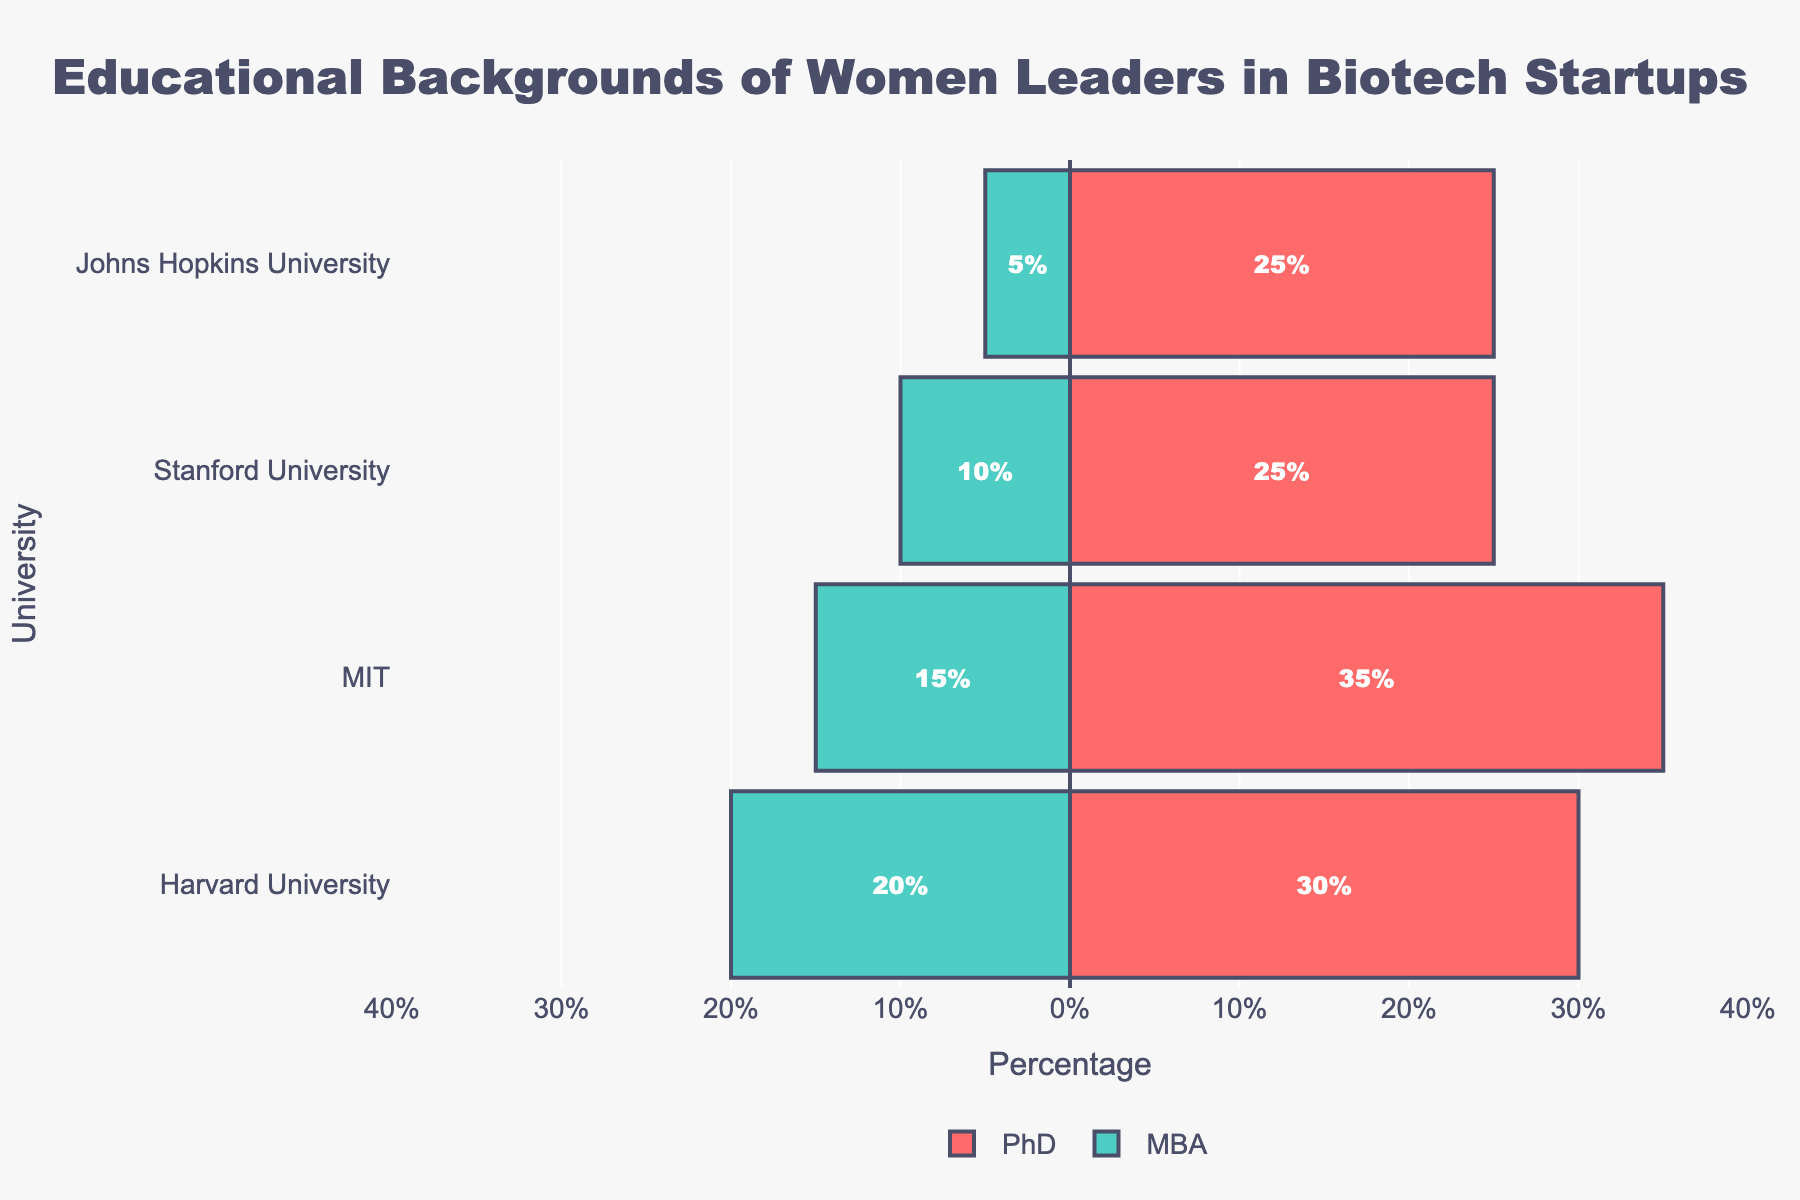What is the university with the highest percentage of PhD holders? To find the university with the highest percentage of PhD holders, look for the longest red bar. MIT has the longest red bar, representing a 35% share of PhD holders.
Answer: MIT Which degree has a higher percentage at Harvard University? At Harvard University, the red bar represents PhD holders (30%) and the green bar represents MBA holders (20%). The red bar is longer, indicating a higher percentage of PhD holders.
Answer: PhD What is the total percentage of MBA holders from Stanford University and Johns Hopkins University combined? From the chart, Stanford University has 10% MBA holders and Johns Hopkins University has 5%. Adding them together (10% + 5%) gives a total of 15%.
Answer: 15% How does the percentage of PhD holders at Johns Hopkins University compare to the percentage of MBA holders at MIT? The percentage of PhD holders at Johns Hopkins University is 25%, and the percentage of MBA holders at MIT is 15%. Comparing the two values, 25% is greater than 15%.
Answer: Greater What is the combined total percentage of PhD and MBA holders from Harvard University? Harvard University has 30% PhD holders and 20% MBA holders. Summing these values (30% + 20%) results in a combined total of 50%.
Answer: 50% Which field of study has the highest combined representation among all universities? By combining the percentages for PhD and MBA in each field across all universities: Biology (30%), Business Administration (30% + 10% = 40%), Biomedical Engineering (25%), Biotechnology (35%), Management (15%), Neuroscience (25%), Healthcare Management (5%). Business Administration has the highest combined representation of 40%.
Answer: Business Administration What is the difference in the percentage of PhD holders between MIT and Stanford University? MIT has 35% PhD holders and Stanford University has 25%. The difference is calculated as 35% - 25%, which equals 10%.
Answer: 10% Which university has the smallest percentage of MBA holders? The shortest green bar represents the university with the smallest percentage of MBA holders. Johns Hopkins University has the shortest green bar with 5%.
Answer: Johns Hopkins University How many universities have more PhD holders than MBA holders? Observing the chart, Harvard University (30% vs 20%), Stanford University (25% vs 10%), MIT (35% vs 15%), and Johns Hopkins University (25% vs 5%). All four universities have more PhD holders than MBA holders.
Answer: 4 